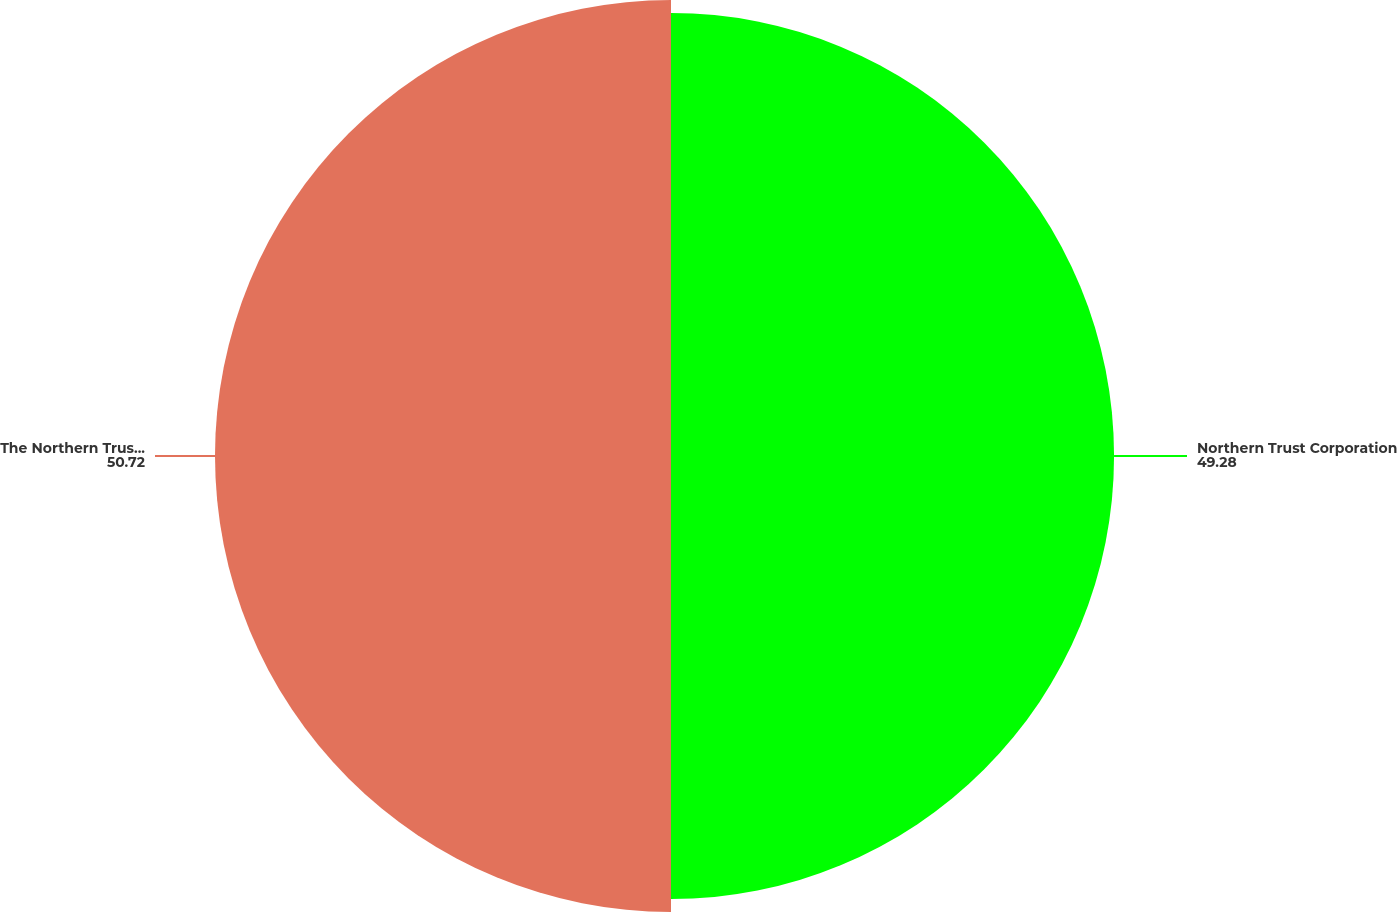<chart> <loc_0><loc_0><loc_500><loc_500><pie_chart><fcel>Northern Trust Corporation<fcel>The Northern Trust Company<nl><fcel>49.28%<fcel>50.72%<nl></chart> 